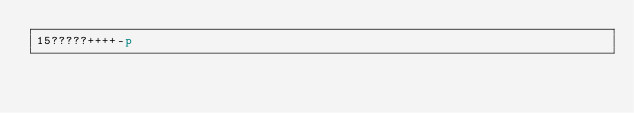Convert code to text. <code><loc_0><loc_0><loc_500><loc_500><_dc_>15?????++++-p</code> 